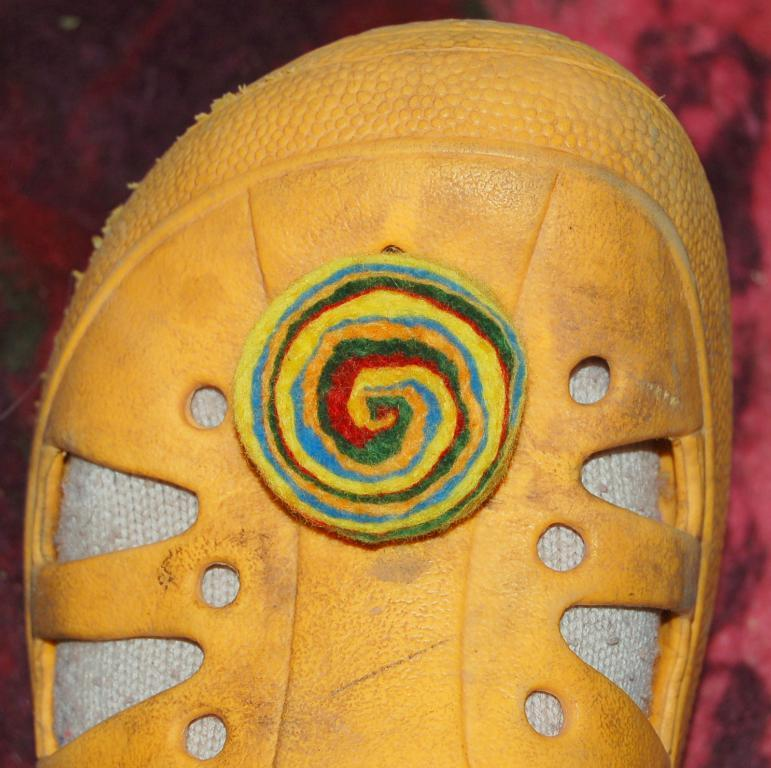What is the main subject in the center of the image? There is a footwear in the center of the image. What color is the footwear? The footwear is in yellow color. Can you touch the footwear in the image? You cannot touch the footwear in the image, as it is a two-dimensional representation. 